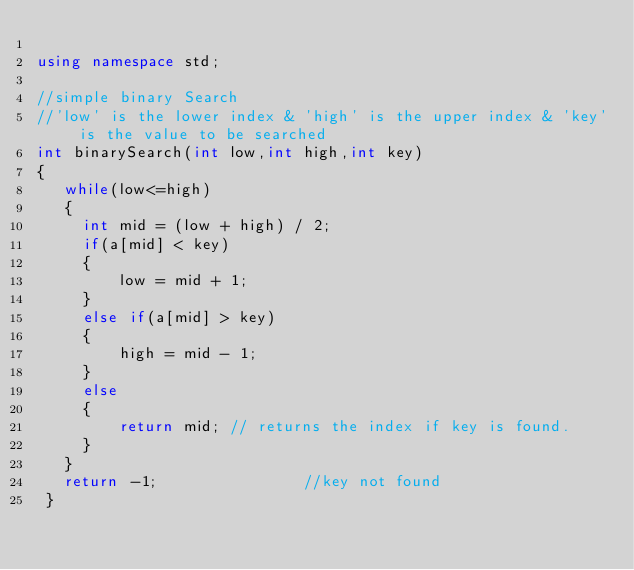<code> <loc_0><loc_0><loc_500><loc_500><_C++_>
using namespace std;

//simple binary Search
//'low' is the lower index & 'high' is the upper index & 'key' is the value to be searched
int binarySearch(int low,int high,int key) 
{
   while(low<=high)
   {
     int mid = (low + high) / 2;
     if(a[mid] < key)
     {
         low = mid + 1;
     }
     else if(a[mid] > key)
     {
         high = mid - 1;
     }
     else
     {
         return mid; // returns the index if key is found.
     }
   }
   return -1;                //key not found
 }
</code> 